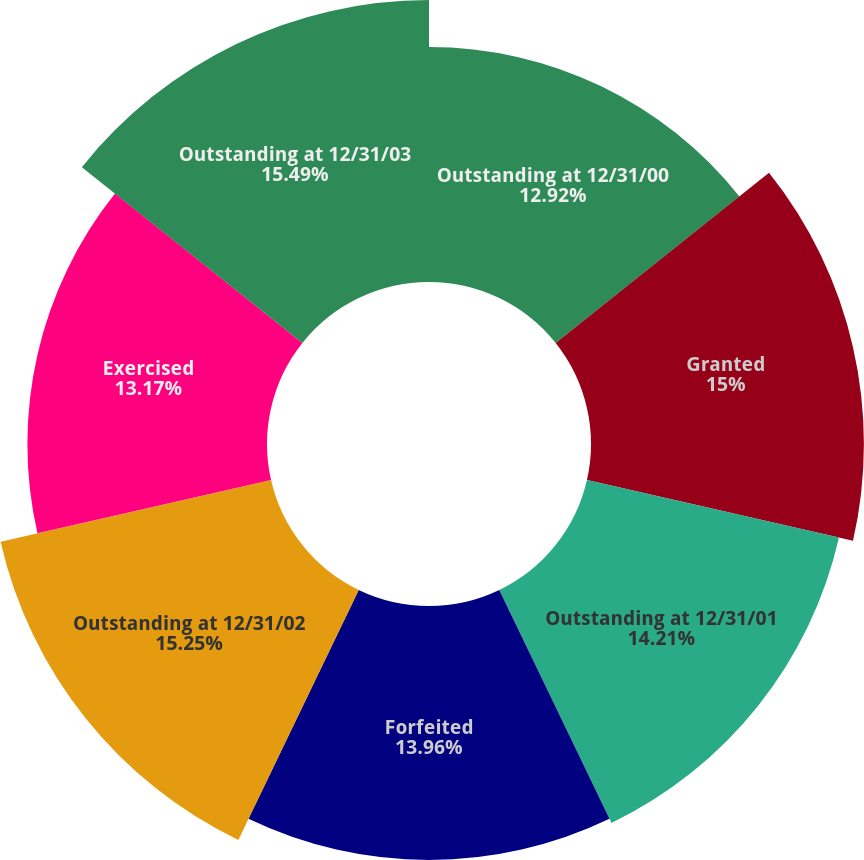Convert chart to OTSL. <chart><loc_0><loc_0><loc_500><loc_500><pie_chart><fcel>Outstanding at 12/31/00<fcel>Granted<fcel>Outstanding at 12/31/01<fcel>Forfeited<fcel>Outstanding at 12/31/02<fcel>Exercised<fcel>Outstanding at 12/31/03<nl><fcel>12.92%<fcel>15.0%<fcel>14.21%<fcel>13.96%<fcel>15.25%<fcel>13.17%<fcel>15.5%<nl></chart> 